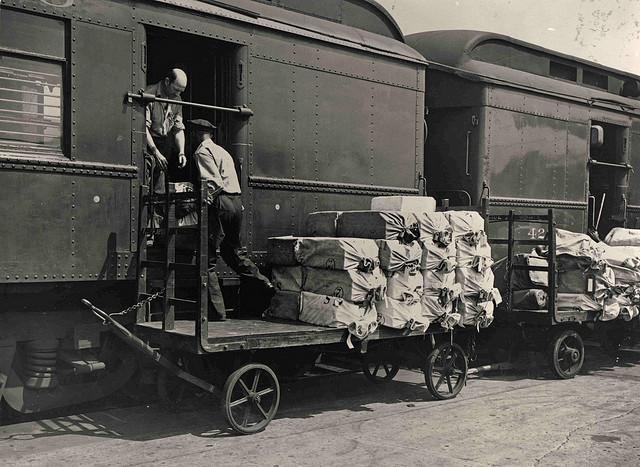How many people are in the picture?
Give a very brief answer. 2. How many reflections of a cat are visible?
Give a very brief answer. 0. 